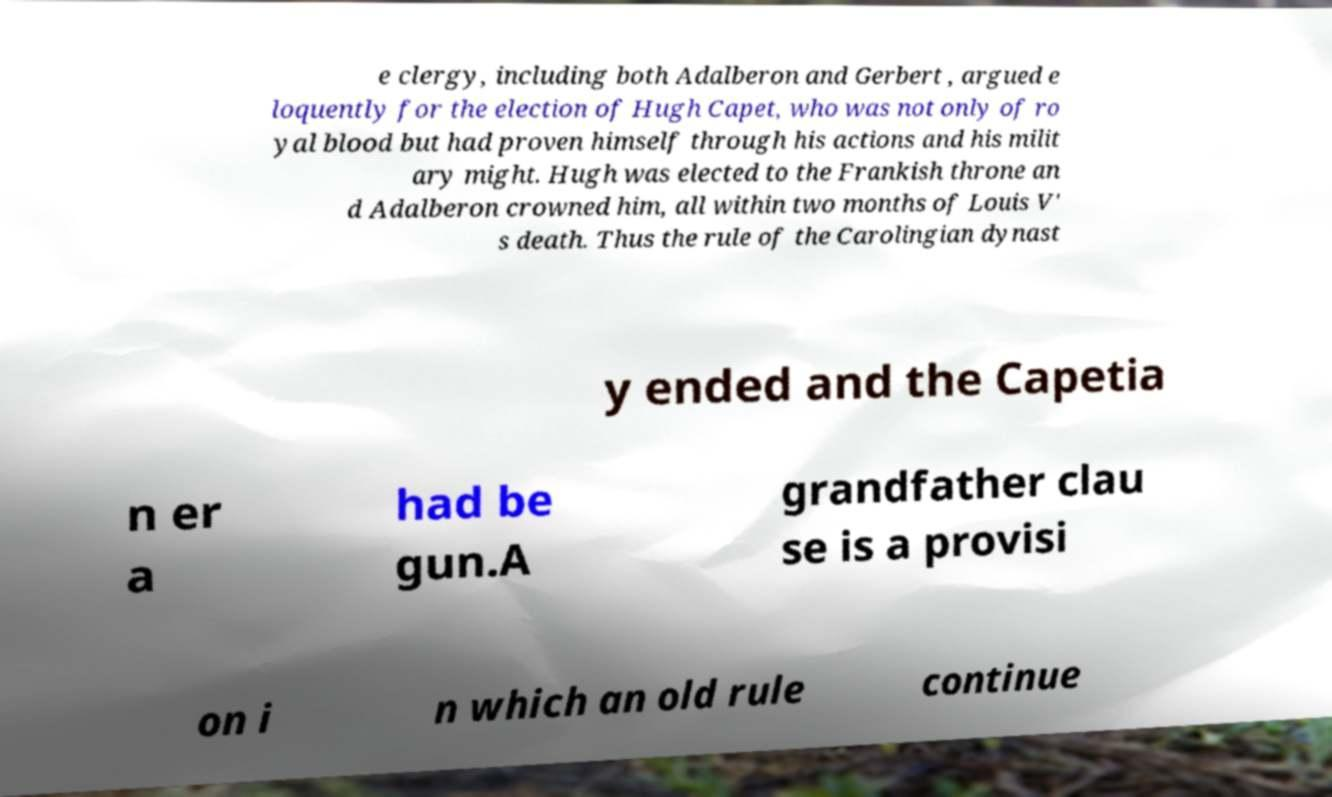I need the written content from this picture converted into text. Can you do that? e clergy, including both Adalberon and Gerbert , argued e loquently for the election of Hugh Capet, who was not only of ro yal blood but had proven himself through his actions and his milit ary might. Hugh was elected to the Frankish throne an d Adalberon crowned him, all within two months of Louis V' s death. Thus the rule of the Carolingian dynast y ended and the Capetia n er a had be gun.A grandfather clau se is a provisi on i n which an old rule continue 